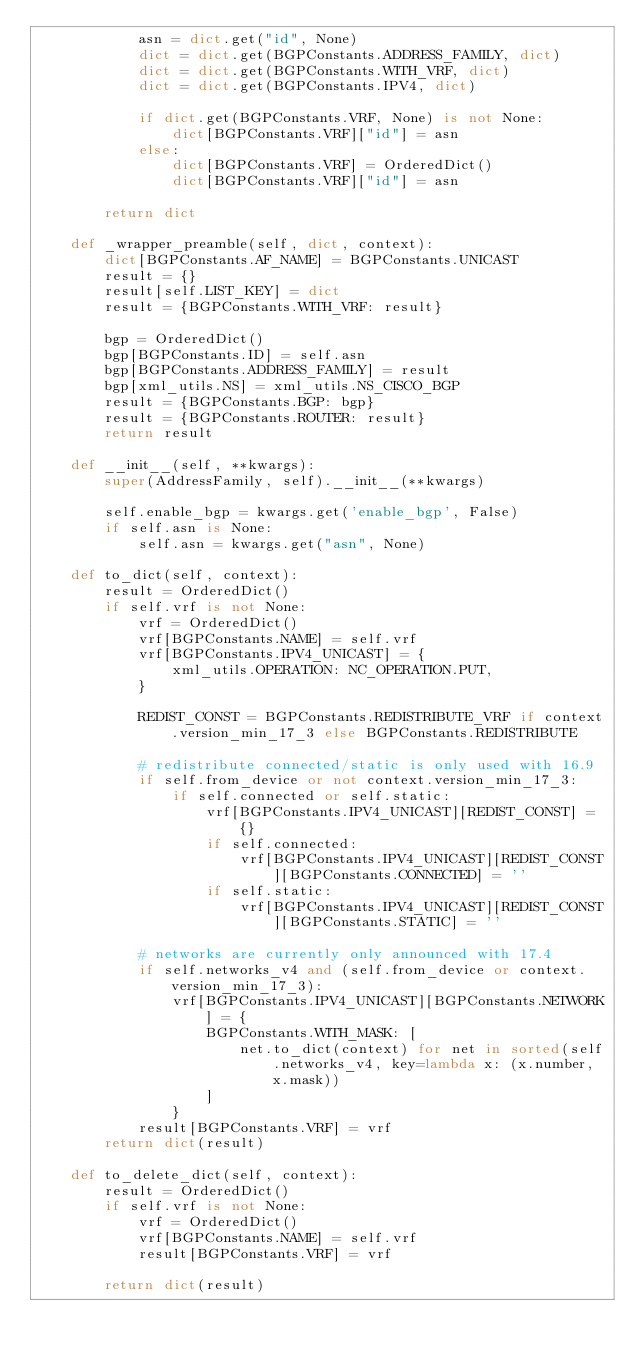Convert code to text. <code><loc_0><loc_0><loc_500><loc_500><_Python_>            asn = dict.get("id", None)
            dict = dict.get(BGPConstants.ADDRESS_FAMILY, dict)
            dict = dict.get(BGPConstants.WITH_VRF, dict)
            dict = dict.get(BGPConstants.IPV4, dict)

            if dict.get(BGPConstants.VRF, None) is not None:
                dict[BGPConstants.VRF]["id"] = asn
            else:
                dict[BGPConstants.VRF] = OrderedDict()
                dict[BGPConstants.VRF]["id"] = asn

        return dict

    def _wrapper_preamble(self, dict, context):
        dict[BGPConstants.AF_NAME] = BGPConstants.UNICAST
        result = {}
        result[self.LIST_KEY] = dict
        result = {BGPConstants.WITH_VRF: result}

        bgp = OrderedDict()
        bgp[BGPConstants.ID] = self.asn
        bgp[BGPConstants.ADDRESS_FAMILY] = result
        bgp[xml_utils.NS] = xml_utils.NS_CISCO_BGP
        result = {BGPConstants.BGP: bgp}
        result = {BGPConstants.ROUTER: result}
        return result

    def __init__(self, **kwargs):
        super(AddressFamily, self).__init__(**kwargs)

        self.enable_bgp = kwargs.get('enable_bgp', False)
        if self.asn is None:
            self.asn = kwargs.get("asn", None)

    def to_dict(self, context):
        result = OrderedDict()
        if self.vrf is not None:
            vrf = OrderedDict()
            vrf[BGPConstants.NAME] = self.vrf
            vrf[BGPConstants.IPV4_UNICAST] = {
                xml_utils.OPERATION: NC_OPERATION.PUT,
            }

            REDIST_CONST = BGPConstants.REDISTRIBUTE_VRF if context.version_min_17_3 else BGPConstants.REDISTRIBUTE

            # redistribute connected/static is only used with 16.9
            if self.from_device or not context.version_min_17_3:
                if self.connected or self.static:
                    vrf[BGPConstants.IPV4_UNICAST][REDIST_CONST] = {}
                    if self.connected:
                        vrf[BGPConstants.IPV4_UNICAST][REDIST_CONST][BGPConstants.CONNECTED] = ''
                    if self.static:
                        vrf[BGPConstants.IPV4_UNICAST][REDIST_CONST][BGPConstants.STATIC] = ''

            # networks are currently only announced with 17.4
            if self.networks_v4 and (self.from_device or context.version_min_17_3):
                vrf[BGPConstants.IPV4_UNICAST][BGPConstants.NETWORK] = {
                    BGPConstants.WITH_MASK: [
                        net.to_dict(context) for net in sorted(self.networks_v4, key=lambda x: (x.number, x.mask))
                    ]
                }
            result[BGPConstants.VRF] = vrf
        return dict(result)

    def to_delete_dict(self, context):
        result = OrderedDict()
        if self.vrf is not None:
            vrf = OrderedDict()
            vrf[BGPConstants.NAME] = self.vrf
            result[BGPConstants.VRF] = vrf

        return dict(result)
</code> 